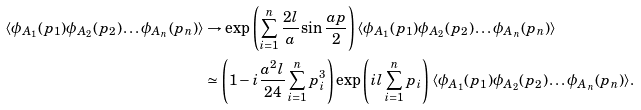Convert formula to latex. <formula><loc_0><loc_0><loc_500><loc_500>\langle \phi _ { A _ { 1 } } ( p _ { 1 } ) \phi _ { A _ { 2 } } ( p _ { 2 } ) \dots \phi _ { A _ { n } } ( p _ { n } ) \rangle & \rightarrow \exp \left ( \sum _ { i = 1 } ^ { n } \frac { 2 l } { a } \sin \frac { a p } { 2 } \right ) \langle \phi _ { A _ { 1 } } ( p _ { 1 } ) \phi _ { A _ { 2 } } ( p _ { 2 } ) \dots \phi _ { A _ { n } } ( p _ { n } ) \rangle \\ & \simeq \left ( 1 - i \frac { a ^ { 2 } l } { 2 4 } \sum _ { i = 1 } ^ { n } p _ { i } ^ { 3 } \right ) \exp \left ( i l \sum _ { i = 1 } ^ { n } p _ { i } \right ) \langle \phi _ { A _ { 1 } } ( p _ { 1 } ) \phi _ { A _ { 2 } } ( p _ { 2 } ) \dots \phi _ { A _ { n } } ( p _ { n } ) \rangle .</formula> 